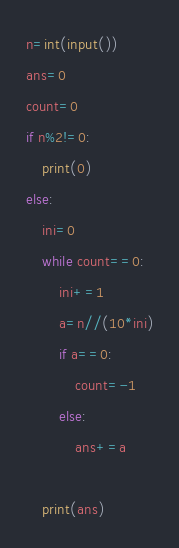<code> <loc_0><loc_0><loc_500><loc_500><_Python_>n=int(input())
ans=0
count=0
if n%2!=0:
    print(0)
else:
    ini=0
    while count==0:
        ini+=1
        a=n//(10*ini)
        if a==0:
            count=-1
        else:
            ans+=a
    
    print(ans)</code> 